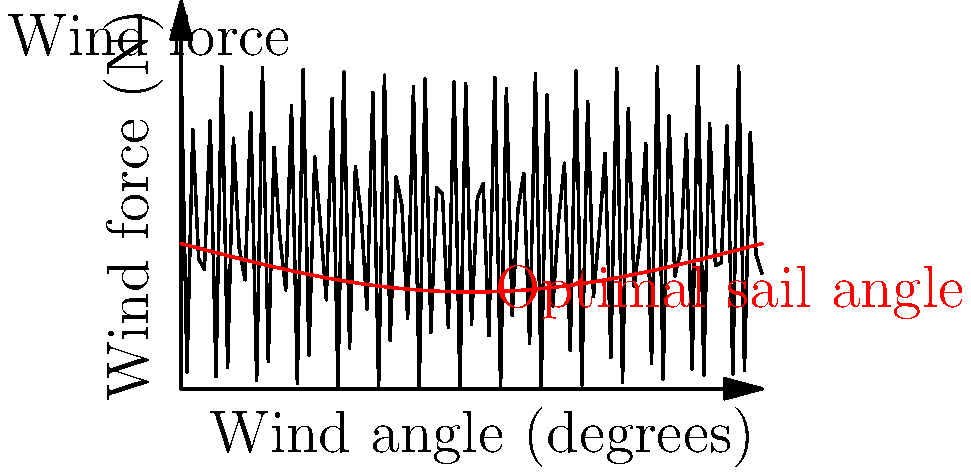As a sailor aboard a British warship, you're tasked with optimizing sail performance. The graph shows the relationship between wind angle and force on the sails (blue curve), as well as the optimal sail angle (red curve) for different wind directions. At what wind angle does the force on the sails reach its maximum value? To find the maximum force on the sails, we need to analyze the blue curve representing wind force:

1. The wind force curve follows a cosine-squared function: $F = F_{max} \cos^2(\theta)$
2. For a cosine-squared function, the maximum occurs at $\theta = 0°$ (and multiples of 360°)
3. In this case, $\theta$ represents the angle between the wind direction and the sail's normal
4. When $\theta = 0°$, the wind is perpendicular to the sail surface
5. On the x-axis, this corresponds to a wind angle of 0°
6. We can verify this by observing that the blue curve peaks at 0° on the x-axis

Therefore, the wind force reaches its maximum when the wind angle is 0°, i.e., when the wind is blowing directly perpendicular to the sail surface.
Answer: 0° 